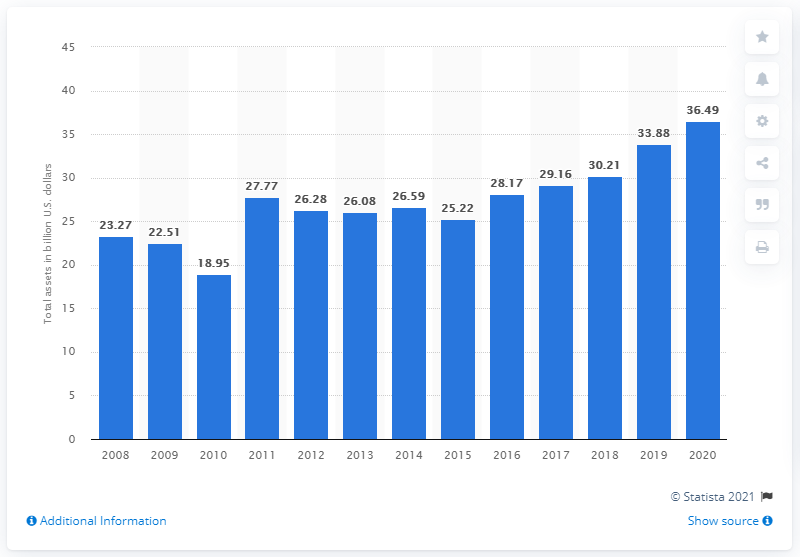Point out several critical features in this image. In 2020, MGM Resorts' total assets were $36.49 billion. The previous year's total assets of MGM Resorts were 33.88. 